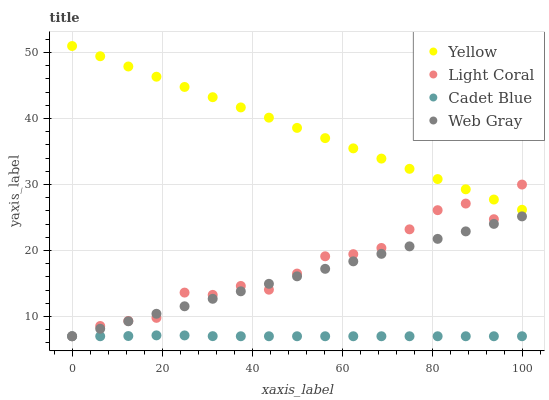Does Cadet Blue have the minimum area under the curve?
Answer yes or no. Yes. Does Yellow have the maximum area under the curve?
Answer yes or no. Yes. Does Web Gray have the minimum area under the curve?
Answer yes or no. No. Does Web Gray have the maximum area under the curve?
Answer yes or no. No. Is Web Gray the smoothest?
Answer yes or no. Yes. Is Light Coral the roughest?
Answer yes or no. Yes. Is Cadet Blue the smoothest?
Answer yes or no. No. Is Cadet Blue the roughest?
Answer yes or no. No. Does Light Coral have the lowest value?
Answer yes or no. Yes. Does Yellow have the lowest value?
Answer yes or no. No. Does Yellow have the highest value?
Answer yes or no. Yes. Does Web Gray have the highest value?
Answer yes or no. No. Is Web Gray less than Yellow?
Answer yes or no. Yes. Is Yellow greater than Cadet Blue?
Answer yes or no. Yes. Does Web Gray intersect Cadet Blue?
Answer yes or no. Yes. Is Web Gray less than Cadet Blue?
Answer yes or no. No. Is Web Gray greater than Cadet Blue?
Answer yes or no. No. Does Web Gray intersect Yellow?
Answer yes or no. No. 